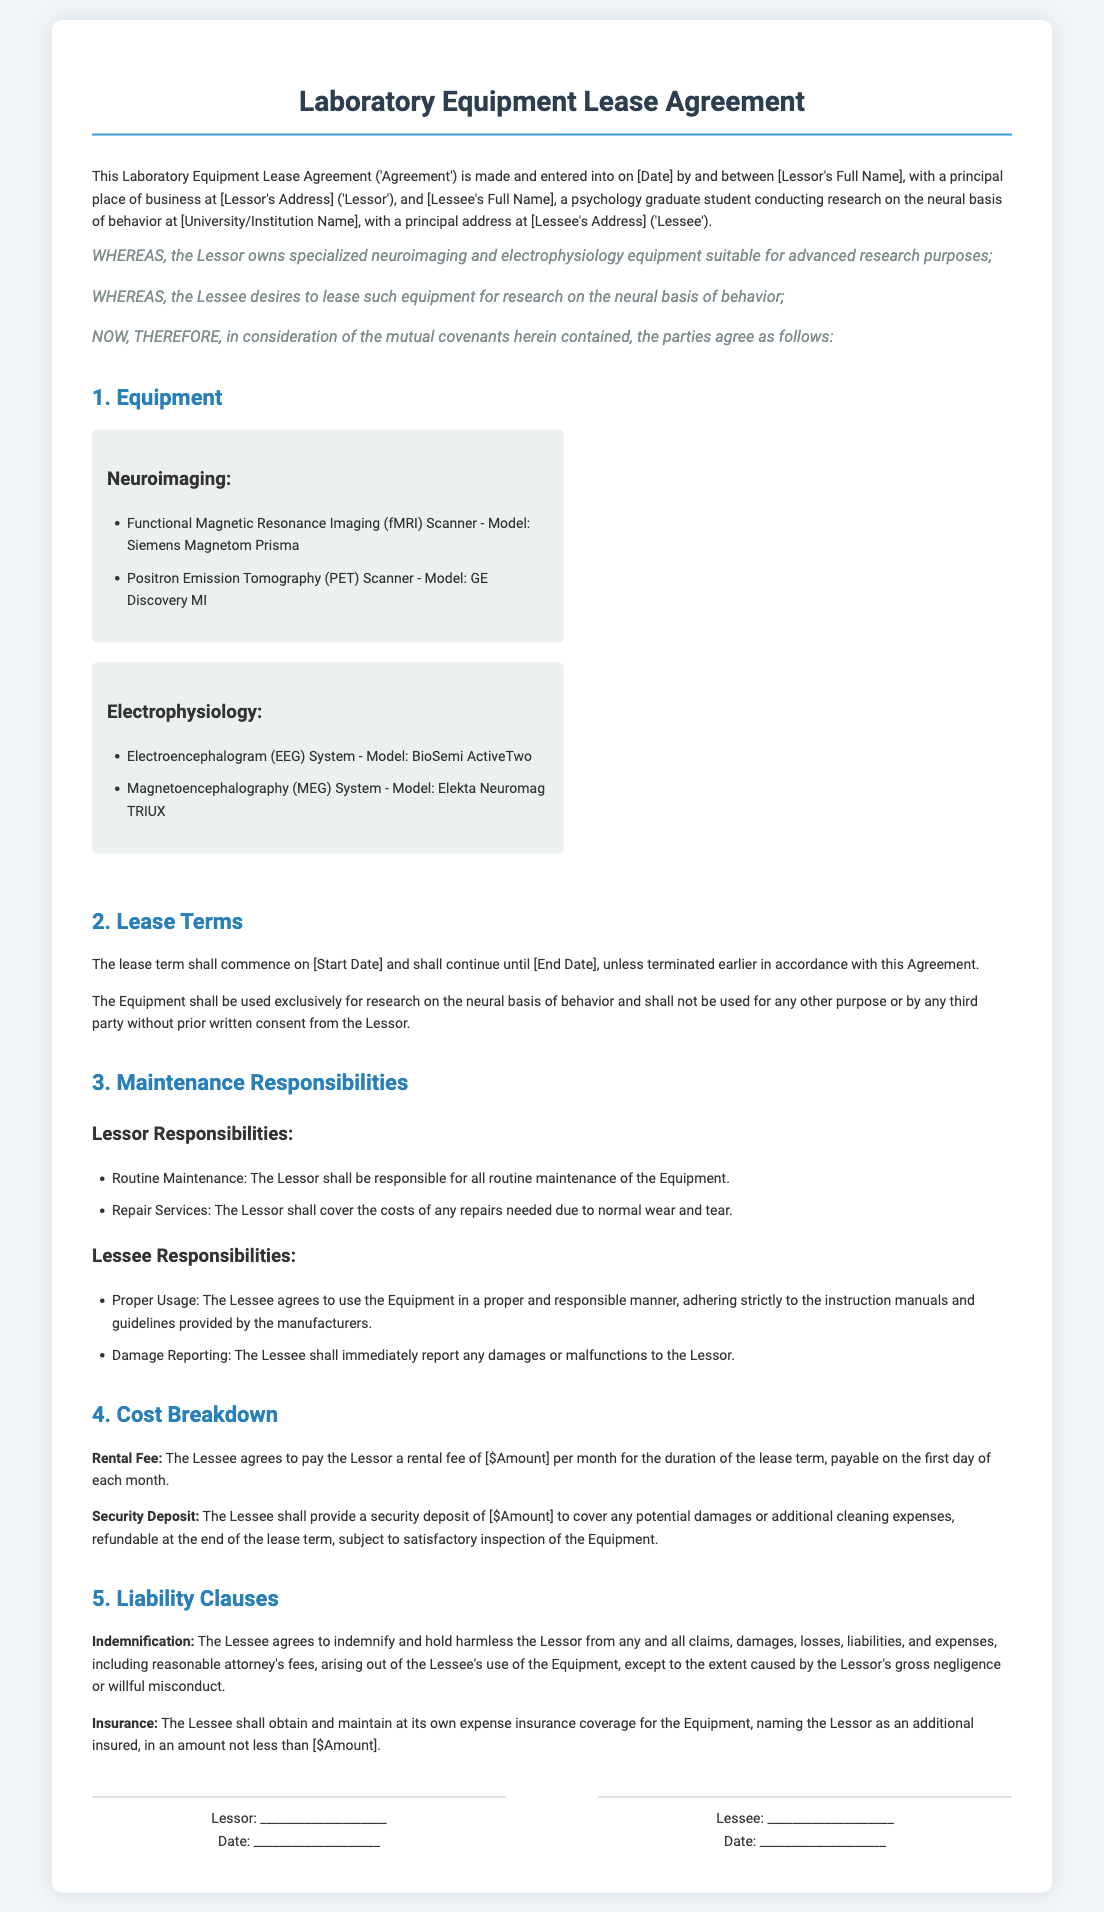what is the Lessor's full name? The Lessor's full name is provided in the document but is listed as a placeholder.
Answer: [Lessor's Full Name] what is the equipment category listed under Neuroimaging? The document lists specific equipment under the Neuroimaging category.
Answer: Functional Magnetic Resonance Imaging (fMRI) Scanner - Model: Siemens Magnetom Prisma what is the monthly rental fee? The rental fee is specified in the document as a certain amount, indicated by a placeholder.
Answer: [$Amount] what is the Lessee's primary research focus? The document indicates the Lessee's focus in the context of their research.
Answer: neural basis of behavior what must the Lessee report immediately to the Lessor? The document specifies the responsibility of the Lessee regarding the Equipment's condition.
Answer: any damages or malfunctions how long is the lease term intended to last? The lease term is mentioned in the document but is left as a placeholder.
Answer: [End Date] what is the security deposit's refund condition? The document specifies the condition under which the security deposit is refundable.
Answer: satisfactory inspection of the Equipment what insurance requirement is stated in the agreement? The document highlights the insurance obligation of the Lessee regarding the Equipment.
Answer: insurance coverage for the Equipment what type of indemnification is required from the Lessee? The document specifies what the Lessee must do regarding claims arising from usage.
Answer: indemnify and hold harmless the Lessor 